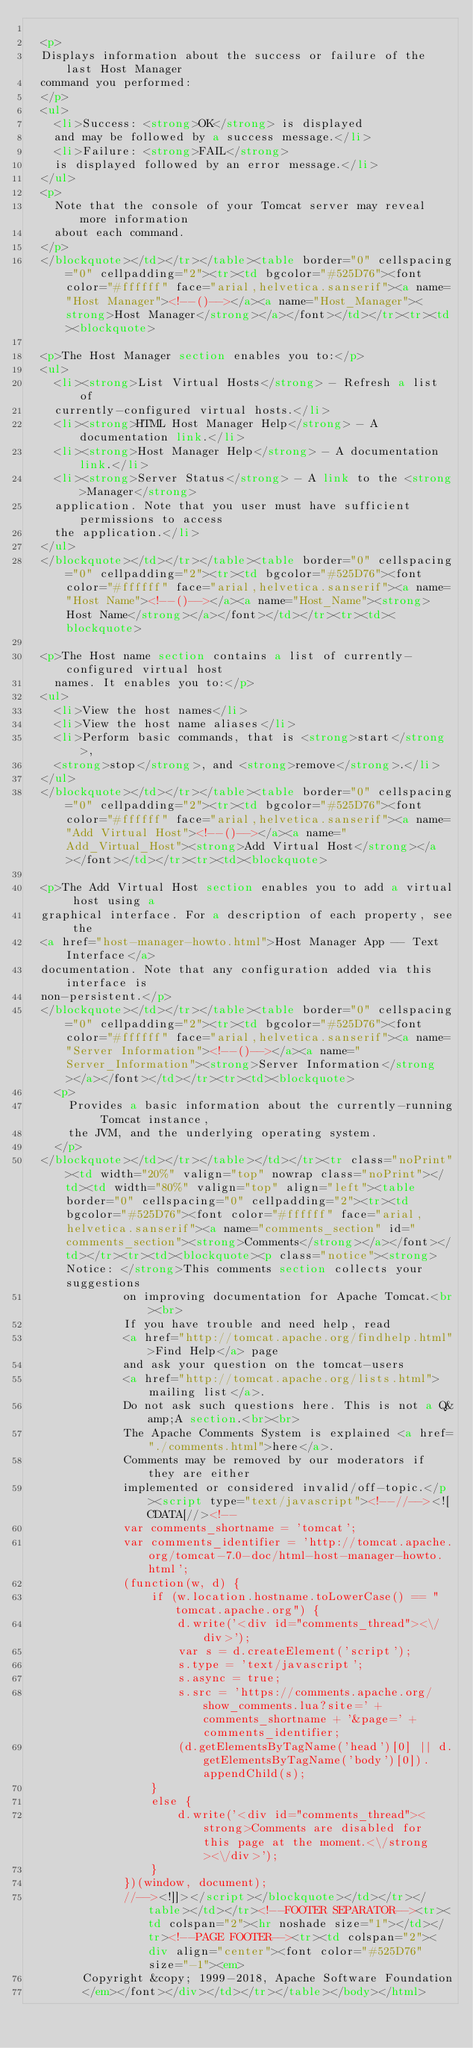Convert code to text. <code><loc_0><loc_0><loc_500><loc_500><_HTML_>
  <p>
  Displays information about the success or failure of the last Host Manager
  command you performed:
  </p>
  <ul>
    <li>Success: <strong>OK</strong> is displayed
    and may be followed by a success message.</li>
    <li>Failure: <strong>FAIL</strong>
    is displayed followed by an error message.</li>
  </ul>
  <p>
    Note that the console of your Tomcat server may reveal more information
    about each command.
  </p>
  </blockquote></td></tr></table><table border="0" cellspacing="0" cellpadding="2"><tr><td bgcolor="#525D76"><font color="#ffffff" face="arial,helvetica.sanserif"><a name="Host Manager"><!--()--></a><a name="Host_Manager"><strong>Host Manager</strong></a></font></td></tr><tr><td><blockquote>

  <p>The Host Manager section enables you to:</p>
  <ul>
    <li><strong>List Virtual Hosts</strong> - Refresh a list of
    currently-configured virtual hosts.</li>
    <li><strong>HTML Host Manager Help</strong> - A documentation link.</li>
    <li><strong>Host Manager Help</strong> - A documentation link.</li>
    <li><strong>Server Status</strong> - A link to the <strong>Manager</strong>
    application. Note that you user must have sufficient permissions to access
    the application.</li>
  </ul>
  </blockquote></td></tr></table><table border="0" cellspacing="0" cellpadding="2"><tr><td bgcolor="#525D76"><font color="#ffffff" face="arial,helvetica.sanserif"><a name="Host Name"><!--()--></a><a name="Host_Name"><strong>Host Name</strong></a></font></td></tr><tr><td><blockquote>

  <p>The Host name section contains a list of currently-configured virtual host
    names. It enables you to:</p>
  <ul>
    <li>View the host names</li>
    <li>View the host name aliases</li>
    <li>Perform basic commands, that is <strong>start</strong>,
    <strong>stop</strong>, and <strong>remove</strong>.</li>
  </ul>
  </blockquote></td></tr></table><table border="0" cellspacing="0" cellpadding="2"><tr><td bgcolor="#525D76"><font color="#ffffff" face="arial,helvetica.sanserif"><a name="Add Virtual Host"><!--()--></a><a name="Add_Virtual_Host"><strong>Add Virtual Host</strong></a></font></td></tr><tr><td><blockquote>

  <p>The Add Virtual Host section enables you to add a virtual host using a
  graphical interface. For a description of each property, see the
  <a href="host-manager-howto.html">Host Manager App -- Text Interface</a>
  documentation. Note that any configuration added via this interface is
  non-persistent.</p>
  </blockquote></td></tr></table><table border="0" cellspacing="0" cellpadding="2"><tr><td bgcolor="#525D76"><font color="#ffffff" face="arial,helvetica.sanserif"><a name="Server Information"><!--()--></a><a name="Server_Information"><strong>Server Information</strong></a></font></td></tr><tr><td><blockquote>
    <p>
      Provides a basic information about the currently-running Tomcat instance,
      the JVM, and the underlying operating system.
    </p>
  </blockquote></td></tr></table></td></tr><tr class="noPrint"><td width="20%" valign="top" nowrap class="noPrint"></td><td width="80%" valign="top" align="left"><table border="0" cellspacing="0" cellpadding="2"><tr><td bgcolor="#525D76"><font color="#ffffff" face="arial,helvetica.sanserif"><a name="comments_section" id="comments_section"><strong>Comments</strong></a></font></td></tr><tr><td><blockquote><p class="notice"><strong>Notice: </strong>This comments section collects your suggestions
              on improving documentation for Apache Tomcat.<br><br>
              If you have trouble and need help, read
              <a href="http://tomcat.apache.org/findhelp.html">Find Help</a> page
              and ask your question on the tomcat-users
              <a href="http://tomcat.apache.org/lists.html">mailing list</a>.
              Do not ask such questions here. This is not a Q&amp;A section.<br><br>
              The Apache Comments System is explained <a href="./comments.html">here</a>.
              Comments may be removed by our moderators if they are either
              implemented or considered invalid/off-topic.</p><script type="text/javascript"><!--//--><![CDATA[//><!--
              var comments_shortname = 'tomcat';
              var comments_identifier = 'http://tomcat.apache.org/tomcat-7.0-doc/html-host-manager-howto.html';
              (function(w, d) {
                  if (w.location.hostname.toLowerCase() == "tomcat.apache.org") {
                      d.write('<div id="comments_thread"><\/div>');
                      var s = d.createElement('script');
                      s.type = 'text/javascript';
                      s.async = true;
                      s.src = 'https://comments.apache.org/show_comments.lua?site=' + comments_shortname + '&page=' + comments_identifier;
                      (d.getElementsByTagName('head')[0] || d.getElementsByTagName('body')[0]).appendChild(s);
                  }
                  else {
                      d.write('<div id="comments_thread"><strong>Comments are disabled for this page at the moment.<\/strong><\/div>');
                  }
              })(window, document);
              //--><!]]></script></blockquote></td></tr></table></td></tr><!--FOOTER SEPARATOR--><tr><td colspan="2"><hr noshade size="1"></td></tr><!--PAGE FOOTER--><tr><td colspan="2"><div align="center"><font color="#525D76" size="-1"><em>
        Copyright &copy; 1999-2018, Apache Software Foundation
        </em></font></div></td></tr></table></body></html></code> 